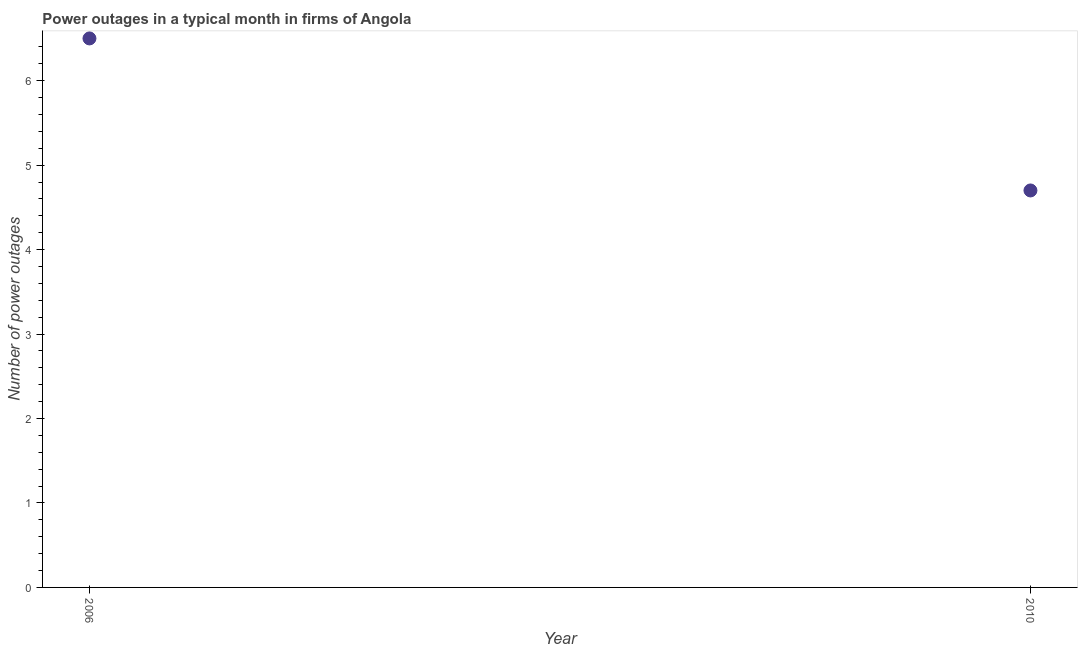Across all years, what is the minimum number of power outages?
Give a very brief answer. 4.7. In which year was the number of power outages minimum?
Offer a very short reply. 2010. What is the difference between the number of power outages in 2006 and 2010?
Ensure brevity in your answer.  1.8. What is the average number of power outages per year?
Keep it short and to the point. 5.6. In how many years, is the number of power outages greater than 3.4 ?
Provide a short and direct response. 2. Do a majority of the years between 2006 and 2010 (inclusive) have number of power outages greater than 3.6 ?
Provide a succinct answer. Yes. What is the ratio of the number of power outages in 2006 to that in 2010?
Provide a short and direct response. 1.38. Is the number of power outages in 2006 less than that in 2010?
Ensure brevity in your answer.  No. Does the number of power outages monotonically increase over the years?
Ensure brevity in your answer.  No. What is the difference between two consecutive major ticks on the Y-axis?
Ensure brevity in your answer.  1. Are the values on the major ticks of Y-axis written in scientific E-notation?
Ensure brevity in your answer.  No. Does the graph contain grids?
Make the answer very short. No. What is the title of the graph?
Give a very brief answer. Power outages in a typical month in firms of Angola. What is the label or title of the Y-axis?
Your answer should be compact. Number of power outages. What is the Number of power outages in 2010?
Offer a terse response. 4.7. What is the ratio of the Number of power outages in 2006 to that in 2010?
Give a very brief answer. 1.38. 